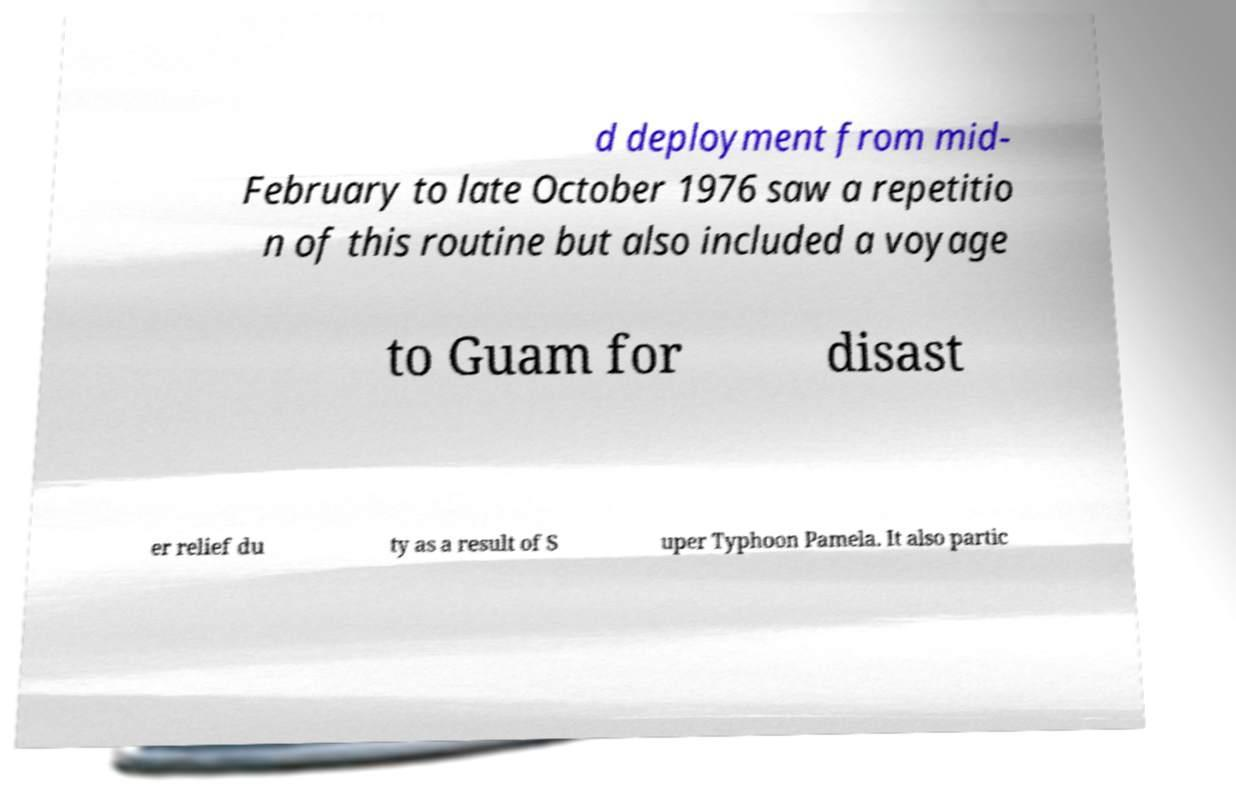What messages or text are displayed in this image? I need them in a readable, typed format. d deployment from mid- February to late October 1976 saw a repetitio n of this routine but also included a voyage to Guam for disast er relief du ty as a result of S uper Typhoon Pamela. It also partic 